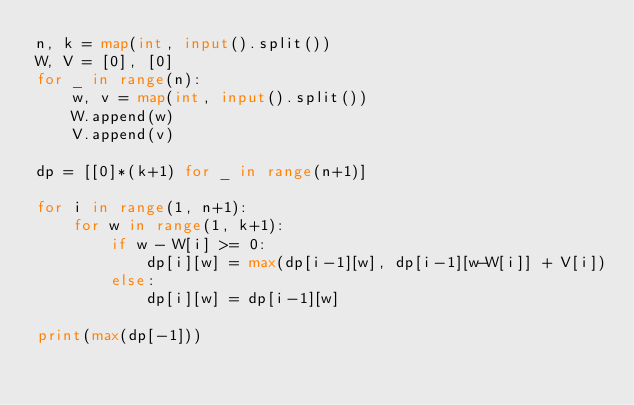Convert code to text. <code><loc_0><loc_0><loc_500><loc_500><_Python_>n, k = map(int, input().split())
W, V = [0], [0]
for _ in range(n):
    w, v = map(int, input().split())
    W.append(w)
    V.append(v)

dp = [[0]*(k+1) for _ in range(n+1)]

for i in range(1, n+1):
    for w in range(1, k+1):
        if w - W[i] >= 0:
            dp[i][w] = max(dp[i-1][w], dp[i-1][w-W[i]] + V[i])
        else:
            dp[i][w] = dp[i-1][w]
            
print(max(dp[-1]))</code> 